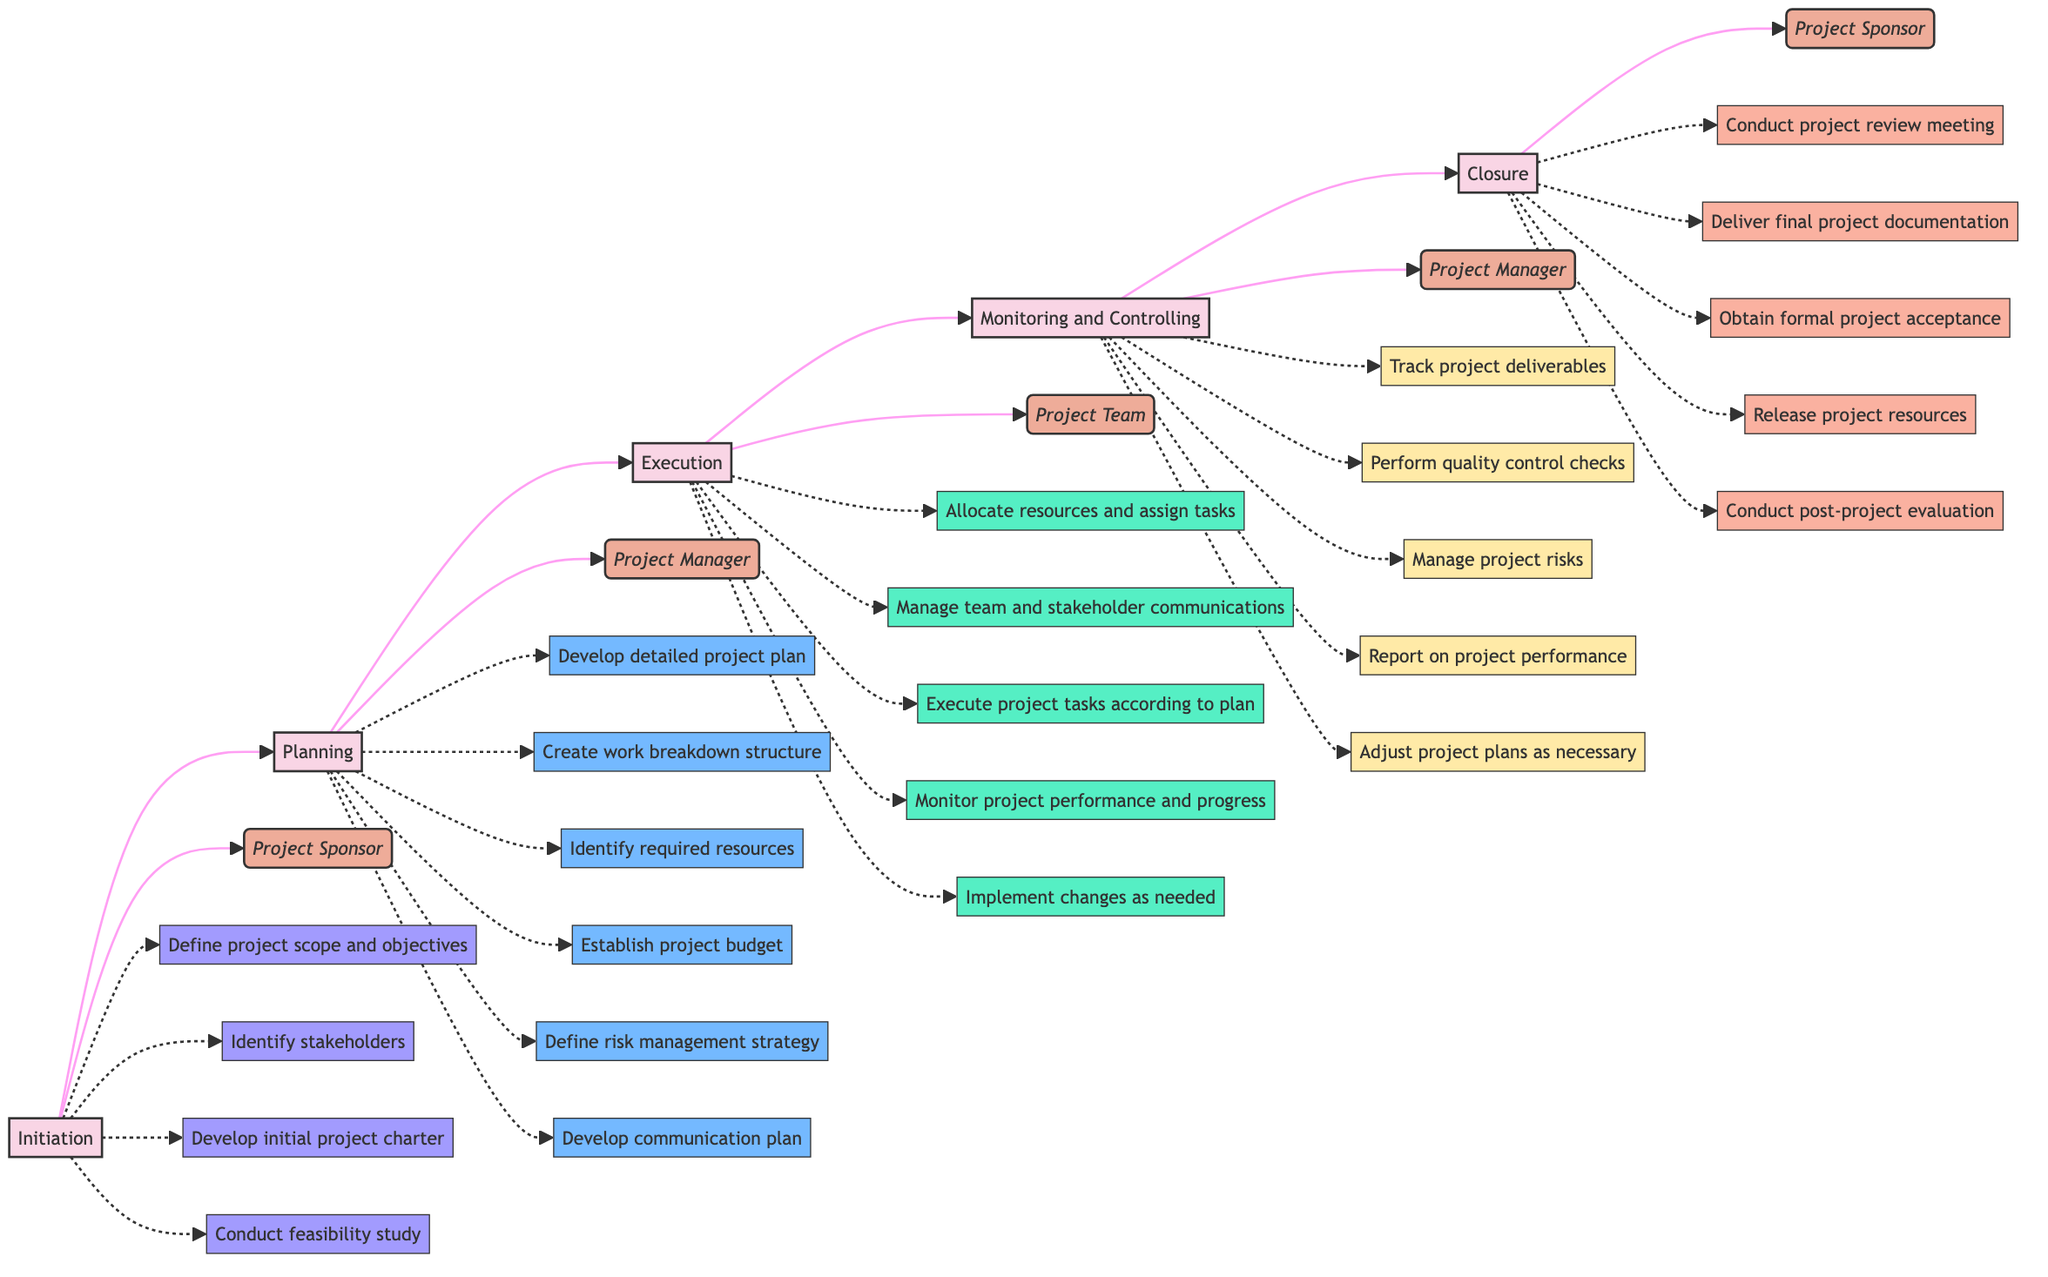What is the first phase in the Project Management Cycle? The diagram clearly indicates that the sequence starts with the node labeled "Initiation," which is the first phase depicted.
Answer: Initiation Who is responsible for the Planning phase? In the diagram, the node corresponding to the Planning phase is connected to the title "Project Manager," indicating that this role is responsible for that phase.
Answer: Project Manager How many key activities are listed for the Execution phase? By examining the Execution phase in the diagram, there are five key activities listed that connect with that phase, as denoted by the respective nodes branching out from the Execution node.
Answer: 5 What phase comes immediately after Monitoring and Controlling? The flowchart demonstrates the direction of the phases, showing that after Monitoring and Controlling, the process flows to the Closure phase, indicating a sequential relationship.
Answer: Closure Name one key activity in the Closure phase. Referencing the Closure phase node, the diagram lists multiple key activities, one of which includes "Conduct project review meeting," showing the activities associated with this phase.
Answer: Conduct project review meeting How many roles are depicted in the Project Management Cycle? In the diagram, each phase is connected to a specific role responsible for its activities, leading to a total of four distinct roles named Project Sponsor, Project Manager, and Project Team, totaling three unique roles.
Answer: 3 What is the last key activity under the Planning phase? By reviewing the nodes associated with the Planning phase in the diagram, the last key activity listed before transitioning to the Execution phase is "Develop communication plan."
Answer: Develop communication plan Which phase is directly linked to both the Project Sponsor and Project Manager roles? The diagram shows that the phases Initiation and Closure are both directly associated with the Project Sponsor, while the Planning and Monitoring and Controlling phases relate to the Project Manager, indicating a clear relationship between the roles and phases.
Answer: Planning and Monitoring and Controlling What type of diagram is used to represent the Project Management Cycle? The current representation aligns with the definition of a horizontal flowchart, highlighting its utilization for process visualization and depicting flow relationships effectively amongst the phases.
Answer: Horizontal flowchart 